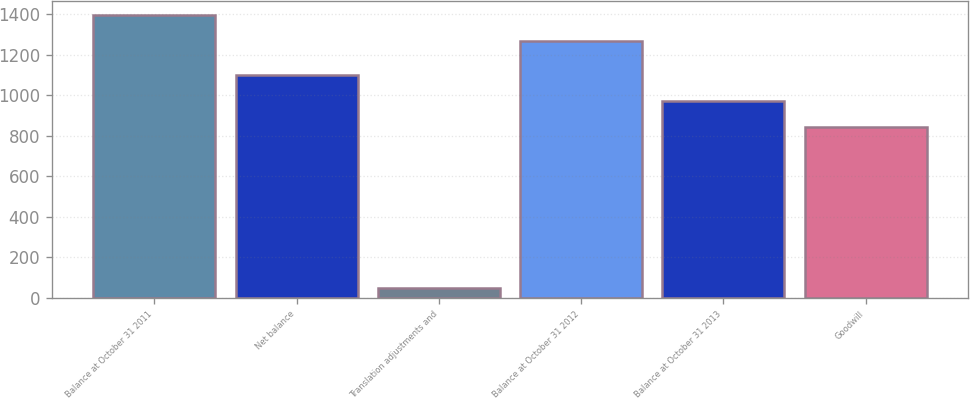Convert chart. <chart><loc_0><loc_0><loc_500><loc_500><bar_chart><fcel>Balance at October 31 2011<fcel>Net balance<fcel>Translation adjustments and<fcel>Balance at October 31 2012<fcel>Balance at October 31 2013<fcel>Goodwill<nl><fcel>1397<fcel>1099<fcel>46<fcel>1270<fcel>972<fcel>845<nl></chart> 